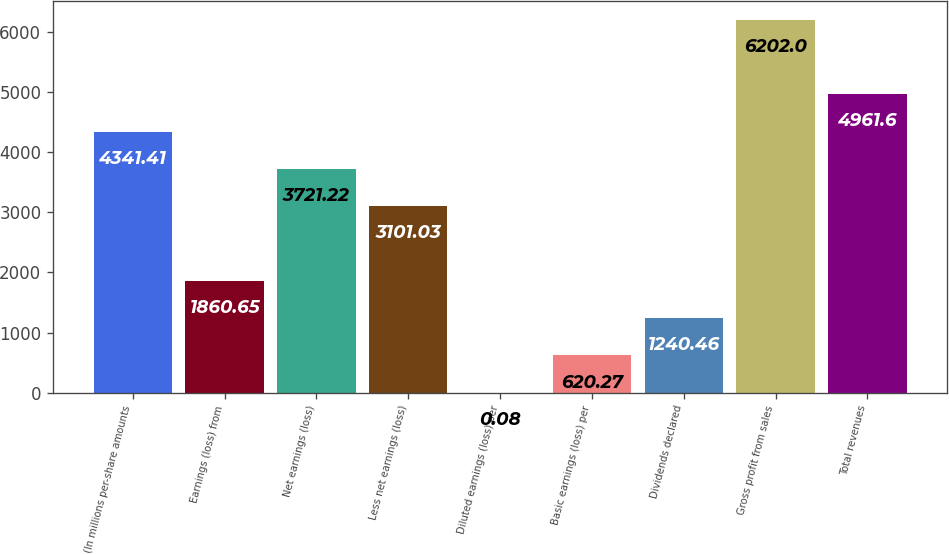<chart> <loc_0><loc_0><loc_500><loc_500><bar_chart><fcel>(In millions per-share amounts<fcel>Earnings (loss) from<fcel>Net earnings (loss)<fcel>Less net earnings (loss)<fcel>Diluted earnings (loss) per<fcel>Basic earnings (loss) per<fcel>Dividends declared<fcel>Gross profit from sales<fcel>Total revenues<nl><fcel>4341.41<fcel>1860.65<fcel>3721.22<fcel>3101.03<fcel>0.08<fcel>620.27<fcel>1240.46<fcel>6202<fcel>4961.6<nl></chart> 